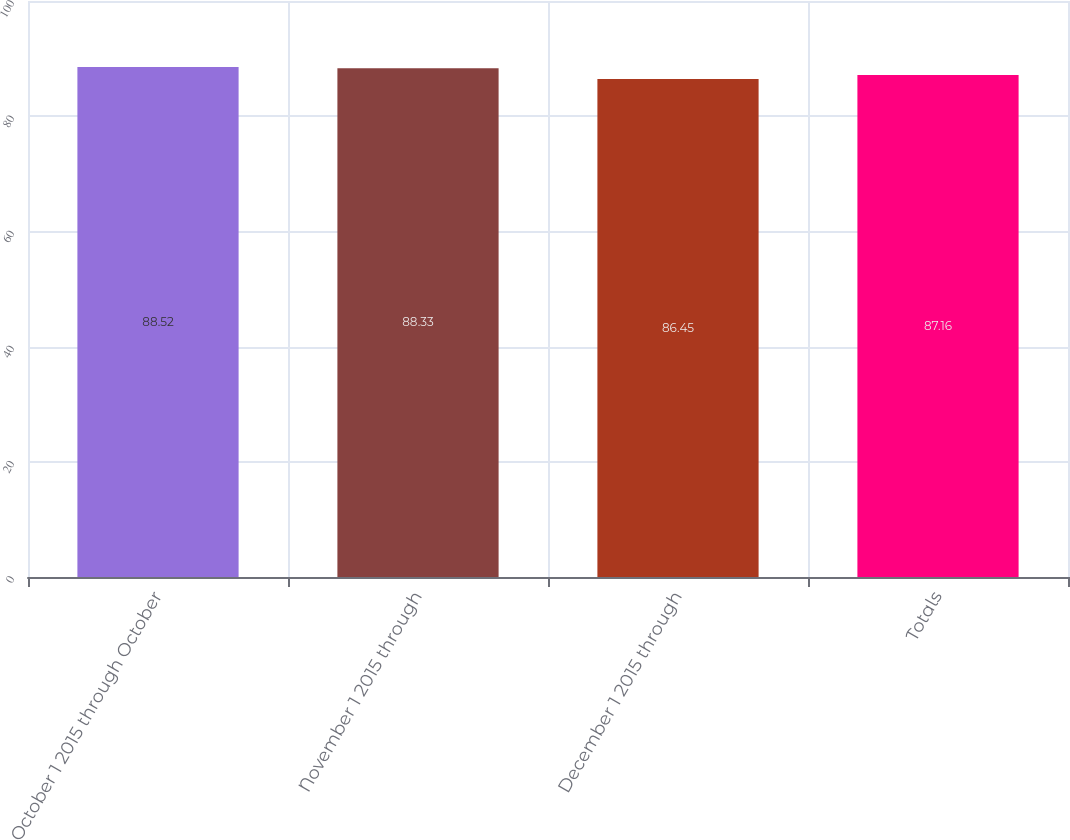Convert chart to OTSL. <chart><loc_0><loc_0><loc_500><loc_500><bar_chart><fcel>October 1 2015 through October<fcel>November 1 2015 through<fcel>December 1 2015 through<fcel>Totals<nl><fcel>88.52<fcel>88.33<fcel>86.45<fcel>87.16<nl></chart> 